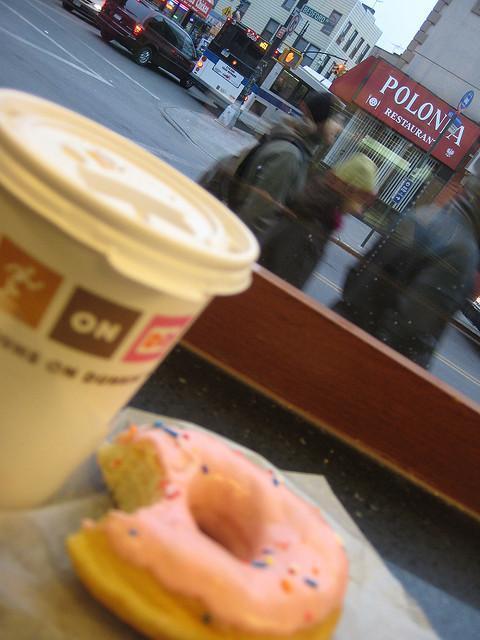Is the statement "The bus is far away from the donut." accurate regarding the image?
Answer yes or no. Yes. Is the caption "The donut is far away from the bus." a true representation of the image?
Answer yes or no. Yes. 